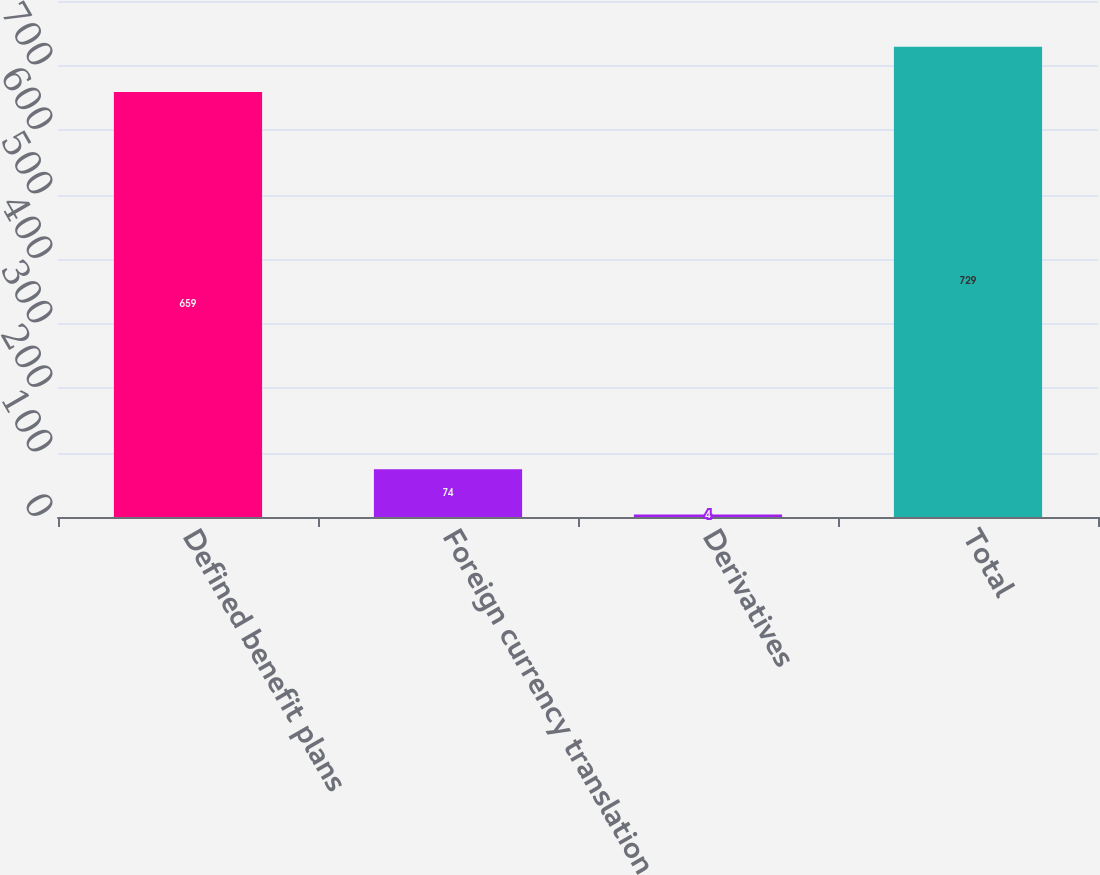Convert chart to OTSL. <chart><loc_0><loc_0><loc_500><loc_500><bar_chart><fcel>Defined benefit plans<fcel>Foreign currency translation<fcel>Derivatives<fcel>Total<nl><fcel>659<fcel>74<fcel>4<fcel>729<nl></chart> 